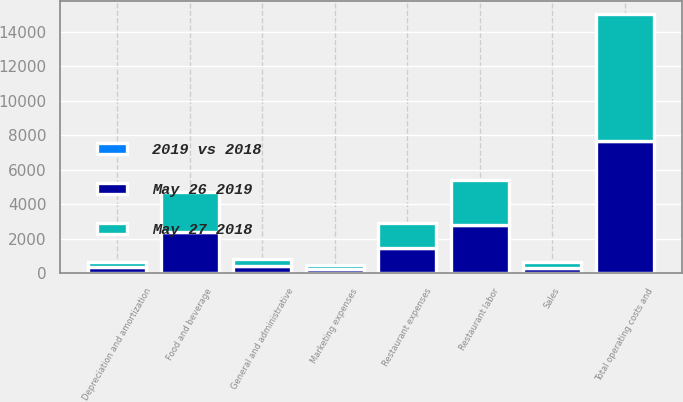<chart> <loc_0><loc_0><loc_500><loc_500><stacked_bar_chart><ecel><fcel>Sales<fcel>Food and beverage<fcel>Restaurant labor<fcel>Restaurant expenses<fcel>Marketing expenses<fcel>General and administrative<fcel>Depreciation and amortization<fcel>Total operating costs and<nl><fcel>May 26 2019<fcel>324.9<fcel>2412.5<fcel>2771.1<fcel>1477.8<fcel>255.3<fcel>405.5<fcel>336.7<fcel>7677.9<nl><fcel>May 27 2018<fcel>324.9<fcel>2303.1<fcel>2614.5<fcel>1417.1<fcel>252.3<fcel>409.8<fcel>313.1<fcel>7313.3<nl><fcel>2019 vs 2018<fcel>5.3<fcel>4.8<fcel>6<fcel>4.3<fcel>1.2<fcel>1<fcel>7.5<fcel>5<nl></chart> 